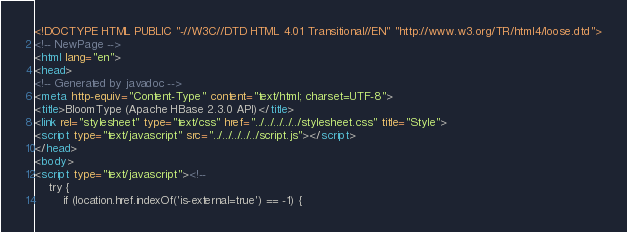Convert code to text. <code><loc_0><loc_0><loc_500><loc_500><_HTML_><!DOCTYPE HTML PUBLIC "-//W3C//DTD HTML 4.01 Transitional//EN" "http://www.w3.org/TR/html4/loose.dtd">
<!-- NewPage -->
<html lang="en">
<head>
<!-- Generated by javadoc -->
<meta http-equiv="Content-Type" content="text/html; charset=UTF-8">
<title>BloomType (Apache HBase 2.3.0 API)</title>
<link rel="stylesheet" type="text/css" href="../../../../../stylesheet.css" title="Style">
<script type="text/javascript" src="../../../../../script.js"></script>
</head>
<body>
<script type="text/javascript"><!--
    try {
        if (location.href.indexOf('is-external=true') == -1) {</code> 